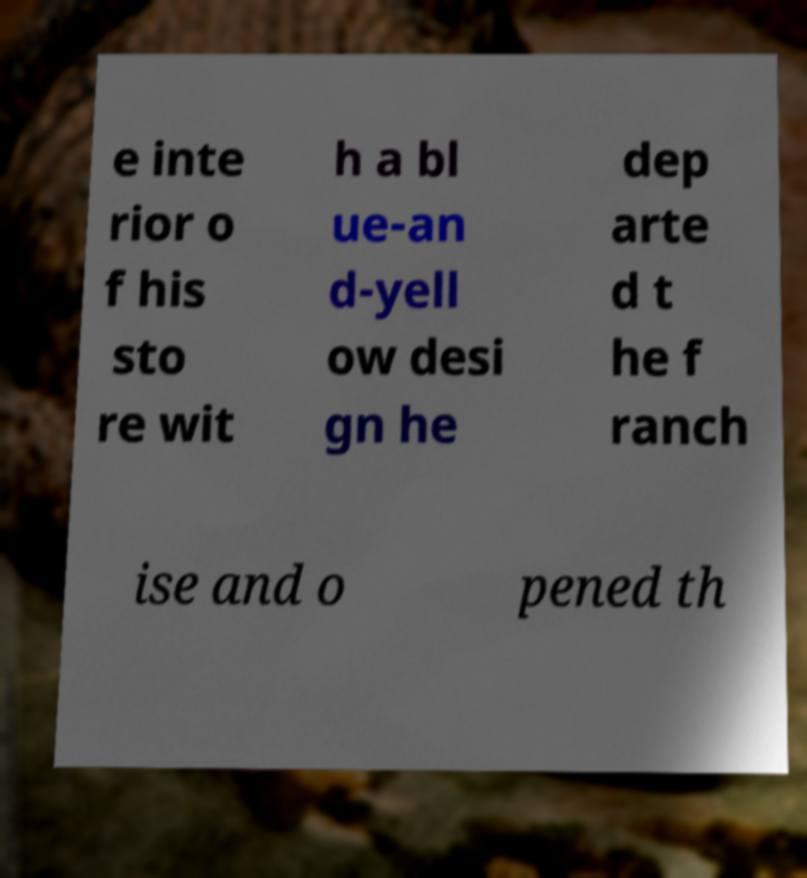Can you read and provide the text displayed in the image?This photo seems to have some interesting text. Can you extract and type it out for me? e inte rior o f his sto re wit h a bl ue-an d-yell ow desi gn he dep arte d t he f ranch ise and o pened th 